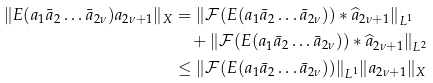<formula> <loc_0><loc_0><loc_500><loc_500>\| E ( a _ { 1 } \bar { a } _ { 2 } \dots \bar { a } _ { 2 \nu } ) a _ { 2 \nu + 1 } \| _ { X } & = \| \mathcal { F } ( E ( a _ { 1 } \bar { a } _ { 2 } \dots \bar { a } _ { 2 \nu } ) ) \ast \widehat { a } _ { 2 \nu + 1 } \| _ { L ^ { 1 } } \\ & \quad + \| \mathcal { F } ( E ( a _ { 1 } \bar { a } _ { 2 } \dots \bar { a } _ { 2 \nu } ) ) \ast \widehat { a } _ { 2 \nu + 1 } \| _ { L ^ { 2 } } \\ & \leq \| \mathcal { F } ( E ( a _ { 1 } \bar { a } _ { 2 } \dots \bar { a } _ { 2 \nu } ) ) \| _ { L ^ { 1 } } \| a _ { 2 \nu + 1 } \| _ { X }</formula> 